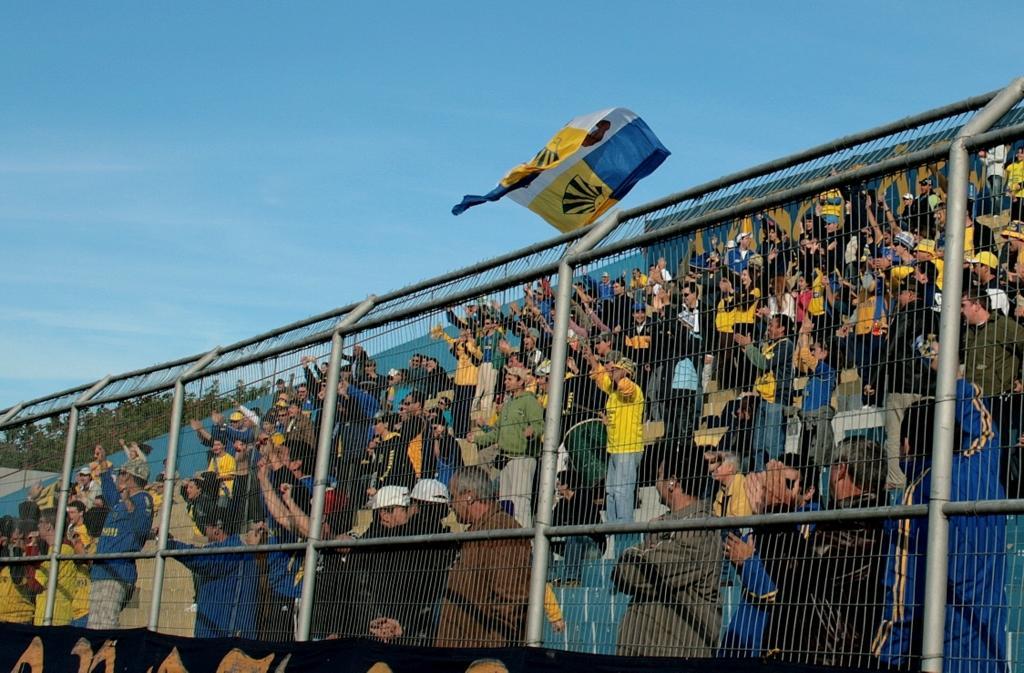Could you give a brief overview of what you see in this image? In this image I can see few people standing and wearing different color dress. I can see a net fencing,banner,trees and flag. The sky is in blue and white color. 